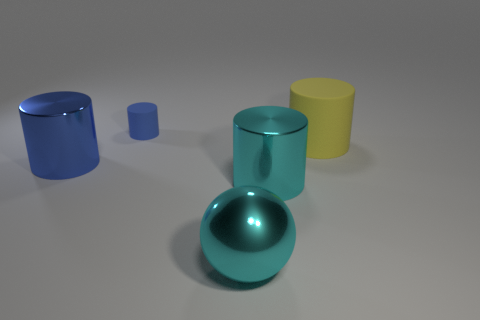Is the number of cyan things that are in front of the yellow matte cylinder less than the number of small yellow blocks?
Your answer should be compact. No. There is a ball that is the same size as the yellow cylinder; what material is it?
Your answer should be compact. Metal. There is a thing that is in front of the small cylinder and on the left side of the large metal ball; how big is it?
Make the answer very short. Large. What size is the other rubber object that is the same shape as the big yellow object?
Provide a short and direct response. Small. How many things are large blue metal cylinders or large metal cylinders that are to the left of the small thing?
Provide a short and direct response. 1. The small blue rubber thing has what shape?
Offer a very short reply. Cylinder. What is the shape of the thing that is left of the blue matte cylinder to the left of the large yellow cylinder?
Ensure brevity in your answer.  Cylinder. There is a large thing that is the same color as the small rubber object; what is its material?
Offer a very short reply. Metal. There is another cylinder that is made of the same material as the small blue cylinder; what color is it?
Provide a succinct answer. Yellow. Is there anything else that has the same size as the cyan metallic sphere?
Ensure brevity in your answer.  Yes. 